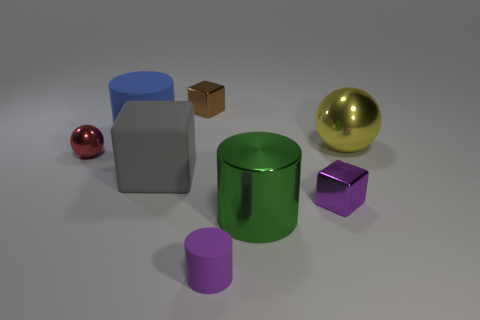Add 1 small brown cubes. How many objects exist? 9 Subtract all cylinders. How many objects are left? 5 Subtract all tiny metallic things. Subtract all tiny purple matte things. How many objects are left? 4 Add 5 tiny purple matte things. How many tiny purple matte things are left? 6 Add 5 small purple matte cylinders. How many small purple matte cylinders exist? 6 Subtract 1 purple blocks. How many objects are left? 7 